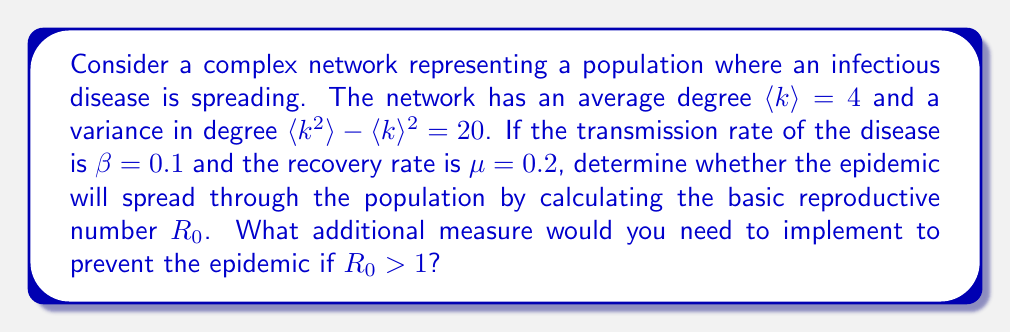What is the answer to this math problem? To solve this problem, we need to follow these steps:

1. Understand the epidemic threshold concept:
   The epidemic threshold is determined by the basic reproductive number $R_0$. If $R_0 > 1$, the epidemic will spread; if $R_0 < 1$, it will die out.

2. Calculate $R_0$ using the formula for complex networks:
   $$R_0 = \frac{\beta}{\mu} \cdot \frac{\langle k^2 \rangle}{\langle k \rangle}$$
   where:
   $\beta$ is the transmission rate
   $\mu$ is the recovery rate
   $\langle k \rangle$ is the average degree
   $\langle k^2 \rangle$ is the second moment of the degree distribution

3. Calculate $\langle k^2 \rangle$:
   We know that $\langle k^2 \rangle - \langle k \rangle^2 = 20$
   $\langle k^2 \rangle = 20 + \langle k \rangle^2 = 20 + 4^2 = 36$

4. Substitute the values into the $R_0$ formula:
   $$R_0 = \frac{0.1}{0.2} \cdot \frac{36}{4} = 0.5 \cdot 9 = 4.5$$

5. Interpret the result:
   Since $R_0 = 4.5 > 1$, the epidemic will spread through the population.

6. Determine additional measure:
   To prevent the epidemic, we need to reduce $R_0$ to below 1. This can be achieved by decreasing $\beta$ or increasing $\mu$. In a practical sense, this could be done through vaccination, which effectively reduces the susceptible population and thus lowers $\beta$.

   To calculate the required vaccination coverage ($p_c$), we can use the formula:
   $$p_c = 1 - \frac{1}{R_0} = 1 - \frac{1}{4.5} \approx 0.78$$

   This means we need to vaccinate at least 78% of the population to prevent the epidemic.
Answer: $R_0 = 4.5$. The epidemic will spread. To prevent it, at least 78% of the population needs to be vaccinated. 